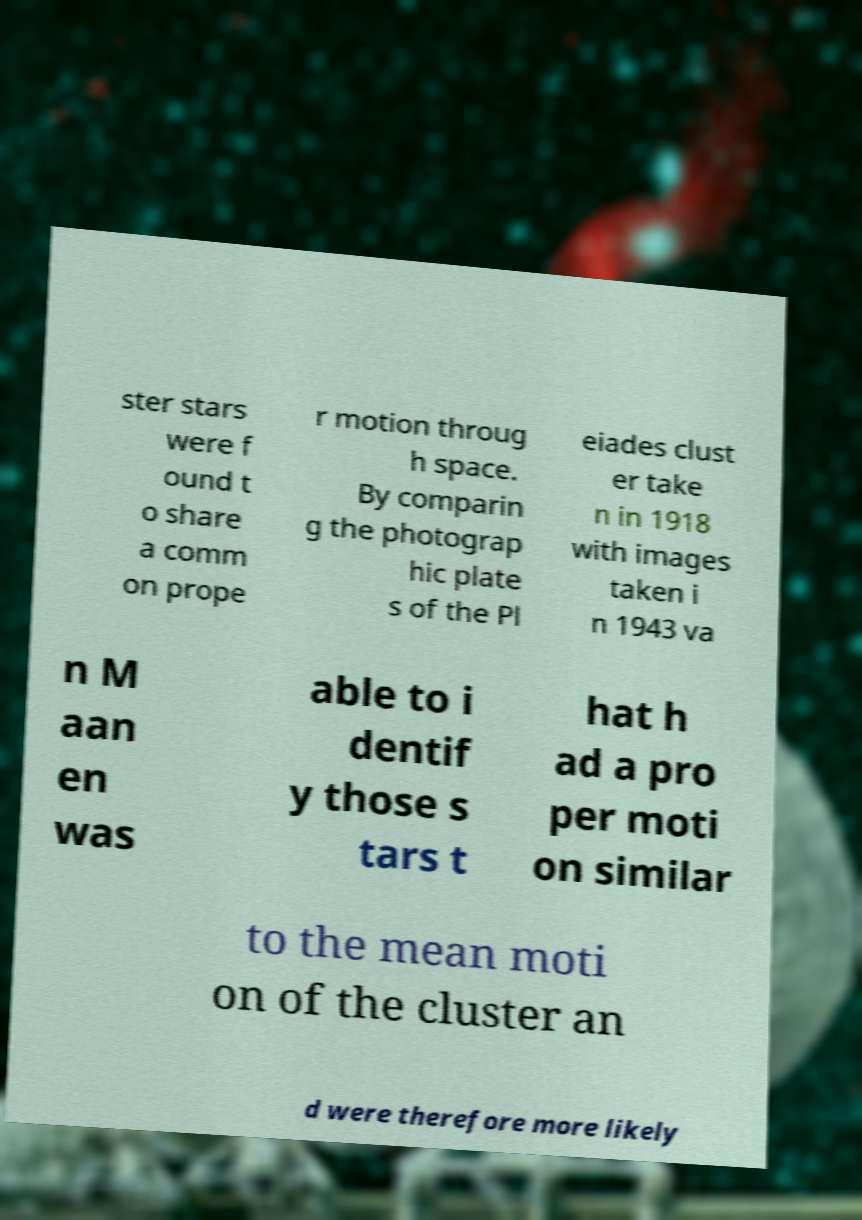There's text embedded in this image that I need extracted. Can you transcribe it verbatim? ster stars were f ound t o share a comm on prope r motion throug h space. By comparin g the photograp hic plate s of the Pl eiades clust er take n in 1918 with images taken i n 1943 va n M aan en was able to i dentif y those s tars t hat h ad a pro per moti on similar to the mean moti on of the cluster an d were therefore more likely 